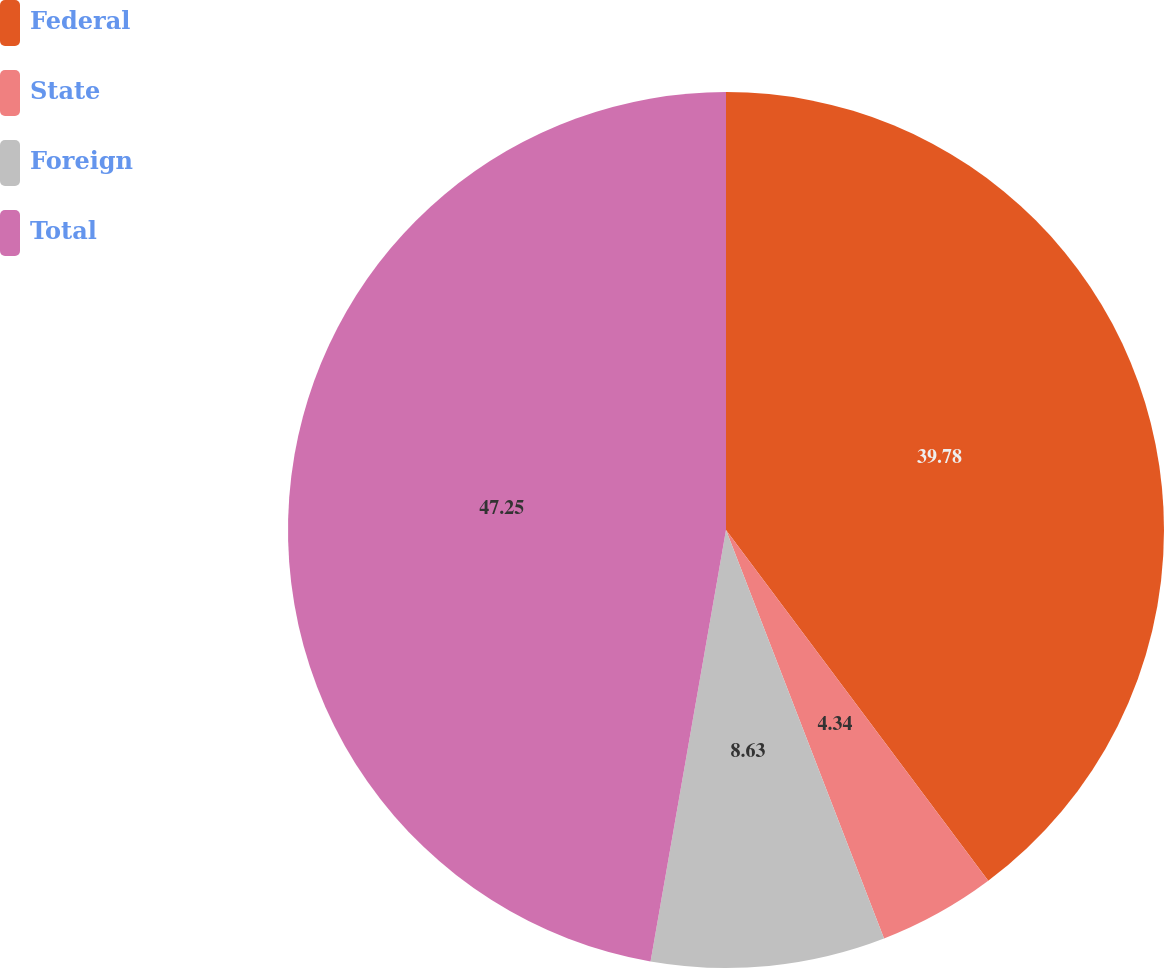<chart> <loc_0><loc_0><loc_500><loc_500><pie_chart><fcel>Federal<fcel>State<fcel>Foreign<fcel>Total<nl><fcel>39.78%<fcel>4.34%<fcel>8.63%<fcel>47.24%<nl></chart> 